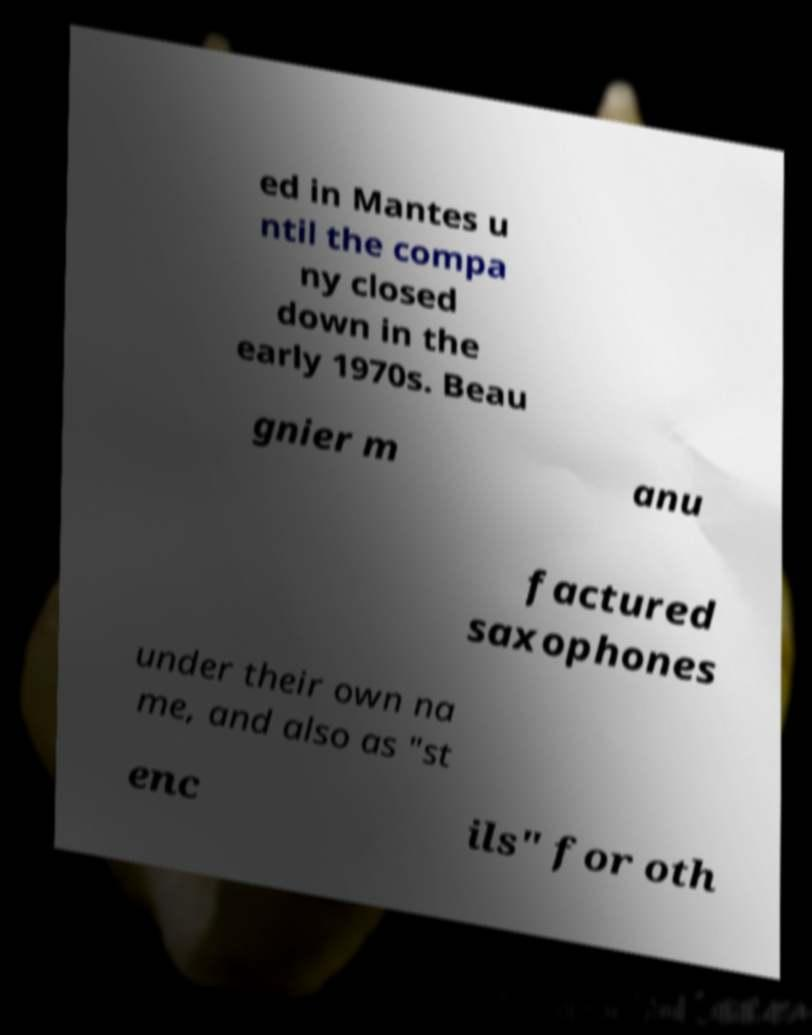What messages or text are displayed in this image? I need them in a readable, typed format. ed in Mantes u ntil the compa ny closed down in the early 1970s. Beau gnier m anu factured saxophones under their own na me, and also as "st enc ils" for oth 